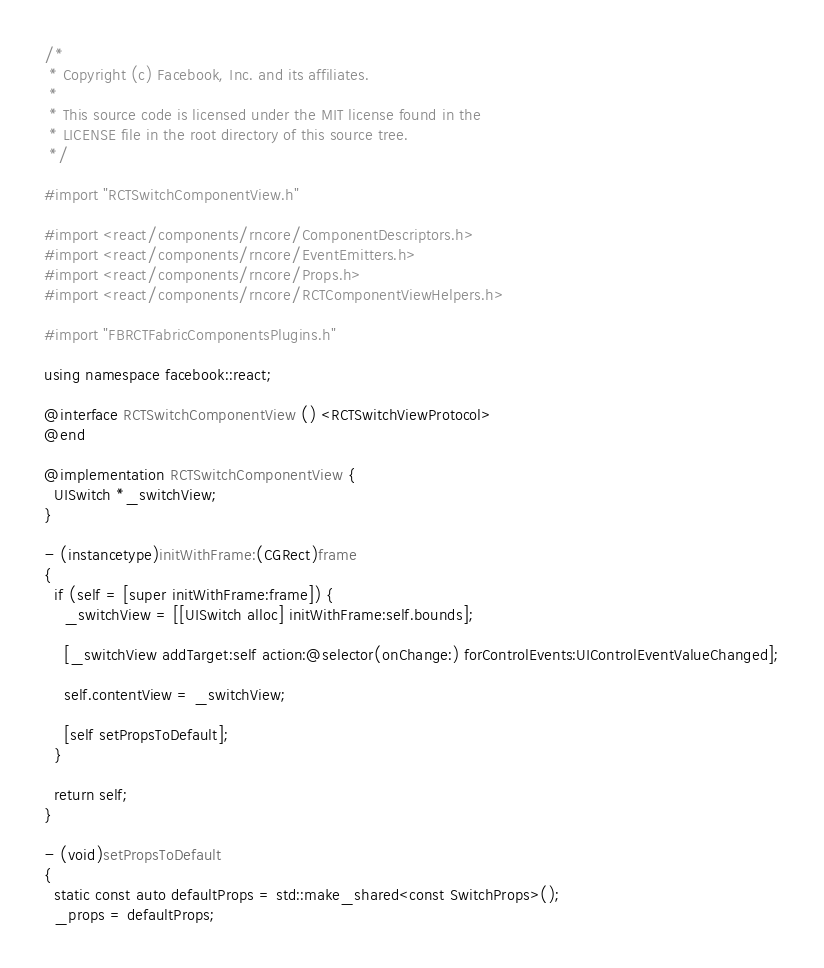<code> <loc_0><loc_0><loc_500><loc_500><_ObjectiveC_>/*
 * Copyright (c) Facebook, Inc. and its affiliates.
 *
 * This source code is licensed under the MIT license found in the
 * LICENSE file in the root directory of this source tree.
 */

#import "RCTSwitchComponentView.h"

#import <react/components/rncore/ComponentDescriptors.h>
#import <react/components/rncore/EventEmitters.h>
#import <react/components/rncore/Props.h>
#import <react/components/rncore/RCTComponentViewHelpers.h>

#import "FBRCTFabricComponentsPlugins.h"

using namespace facebook::react;

@interface RCTSwitchComponentView () <RCTSwitchViewProtocol>
@end

@implementation RCTSwitchComponentView {
  UISwitch *_switchView;
}

- (instancetype)initWithFrame:(CGRect)frame
{
  if (self = [super initWithFrame:frame]) {
    _switchView = [[UISwitch alloc] initWithFrame:self.bounds];

    [_switchView addTarget:self action:@selector(onChange:) forControlEvents:UIControlEventValueChanged];

    self.contentView = _switchView;

    [self setPropsToDefault];
  }

  return self;
}

- (void)setPropsToDefault
{
  static const auto defaultProps = std::make_shared<const SwitchProps>();
  _props = defaultProps;</code> 